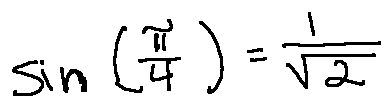<formula> <loc_0><loc_0><loc_500><loc_500>\sin ( \frac { \pi } { 4 } ) = \frac { 1 } { \sqrt { 2 } }</formula> 